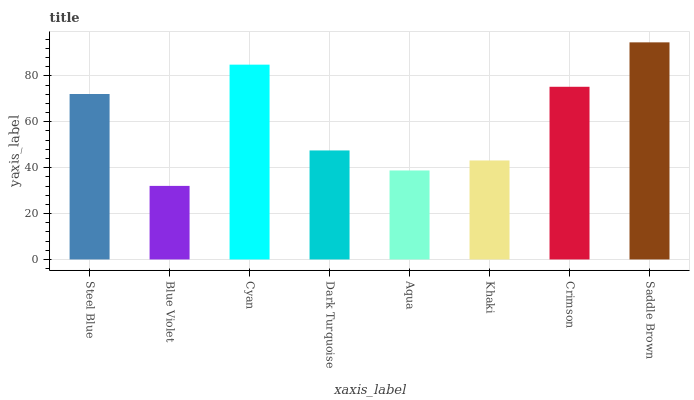Is Blue Violet the minimum?
Answer yes or no. Yes. Is Saddle Brown the maximum?
Answer yes or no. Yes. Is Cyan the minimum?
Answer yes or no. No. Is Cyan the maximum?
Answer yes or no. No. Is Cyan greater than Blue Violet?
Answer yes or no. Yes. Is Blue Violet less than Cyan?
Answer yes or no. Yes. Is Blue Violet greater than Cyan?
Answer yes or no. No. Is Cyan less than Blue Violet?
Answer yes or no. No. Is Steel Blue the high median?
Answer yes or no. Yes. Is Dark Turquoise the low median?
Answer yes or no. Yes. Is Dark Turquoise the high median?
Answer yes or no. No. Is Khaki the low median?
Answer yes or no. No. 